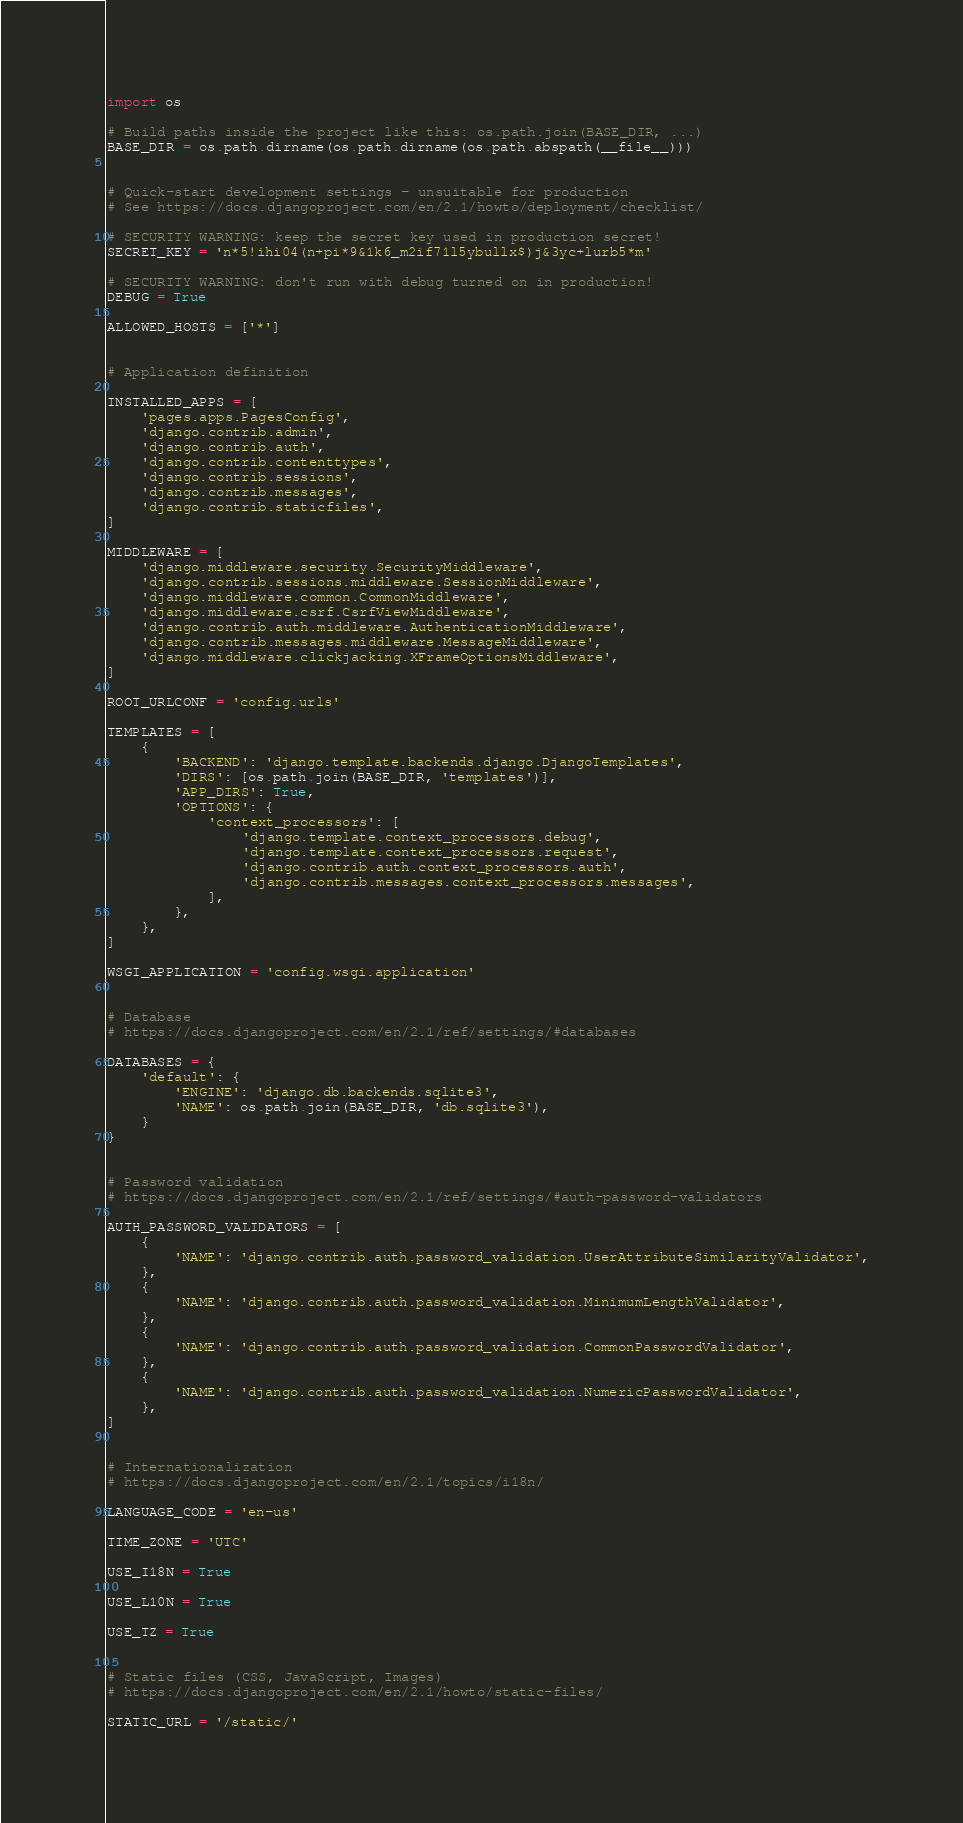<code> <loc_0><loc_0><loc_500><loc_500><_Python_>import os

# Build paths inside the project like this: os.path.join(BASE_DIR, ...)
BASE_DIR = os.path.dirname(os.path.dirname(os.path.abspath(__file__)))


# Quick-start development settings - unsuitable for production
# See https://docs.djangoproject.com/en/2.1/howto/deployment/checklist/

# SECURITY WARNING: keep the secret key used in production secret!
SECRET_KEY = 'n*5!ihi04(n+pi*9&1k6_m2if71l5ybullx$)j&3yc+lurb5*m'

# SECURITY WARNING: don't run with debug turned on in production!
DEBUG = True

ALLOWED_HOSTS = ['*']


# Application definition

INSTALLED_APPS = [
    'pages.apps.PagesConfig',
    'django.contrib.admin',
    'django.contrib.auth',
    'django.contrib.contenttypes',
    'django.contrib.sessions',
    'django.contrib.messages',
    'django.contrib.staticfiles',
]

MIDDLEWARE = [
    'django.middleware.security.SecurityMiddleware',
    'django.contrib.sessions.middleware.SessionMiddleware',
    'django.middleware.common.CommonMiddleware',
    'django.middleware.csrf.CsrfViewMiddleware',
    'django.contrib.auth.middleware.AuthenticationMiddleware',
    'django.contrib.messages.middleware.MessageMiddleware',
    'django.middleware.clickjacking.XFrameOptionsMiddleware',
]

ROOT_URLCONF = 'config.urls'

TEMPLATES = [
    {
        'BACKEND': 'django.template.backends.django.DjangoTemplates',
        'DIRS': [os.path.join(BASE_DIR, 'templates')],
        'APP_DIRS': True,
        'OPTIONS': {
            'context_processors': [
                'django.template.context_processors.debug',
                'django.template.context_processors.request',
                'django.contrib.auth.context_processors.auth',
                'django.contrib.messages.context_processors.messages',
            ],
        },
    },
]

WSGI_APPLICATION = 'config.wsgi.application'


# Database
# https://docs.djangoproject.com/en/2.1/ref/settings/#databases

DATABASES = {
    'default': {
        'ENGINE': 'django.db.backends.sqlite3',
        'NAME': os.path.join(BASE_DIR, 'db.sqlite3'),
    }
}


# Password validation
# https://docs.djangoproject.com/en/2.1/ref/settings/#auth-password-validators

AUTH_PASSWORD_VALIDATORS = [
    {
        'NAME': 'django.contrib.auth.password_validation.UserAttributeSimilarityValidator',
    },
    {
        'NAME': 'django.contrib.auth.password_validation.MinimumLengthValidator',
    },
    {
        'NAME': 'django.contrib.auth.password_validation.CommonPasswordValidator',
    },
    {
        'NAME': 'django.contrib.auth.password_validation.NumericPasswordValidator',
    },
]


# Internationalization
# https://docs.djangoproject.com/en/2.1/topics/i18n/

LANGUAGE_CODE = 'en-us'

TIME_ZONE = 'UTC'

USE_I18N = True

USE_L10N = True

USE_TZ = True


# Static files (CSS, JavaScript, Images)
# https://docs.djangoproject.com/en/2.1/howto/static-files/

STATIC_URL = '/static/'
</code> 